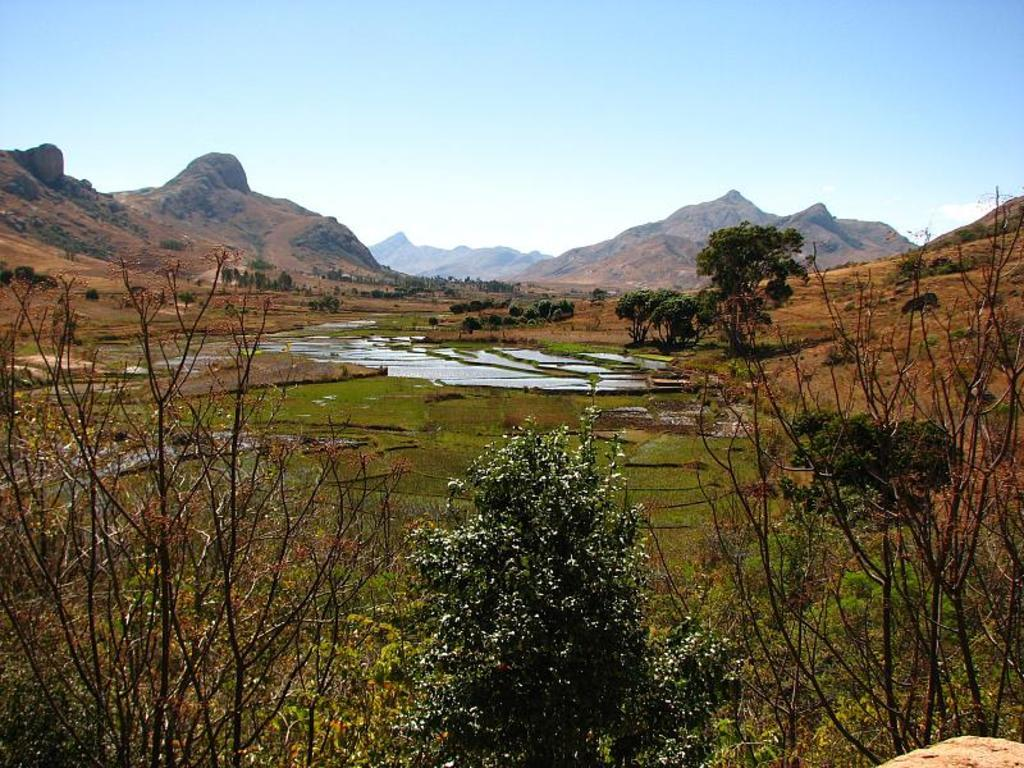What type of landscape is depicted in the image? The image shows farm land. What natural elements can be seen in the image? Water, trees, plants, and grass are visible in the image. What is visible in the background of the image? There are mountains visible in the background of the image. Can you tell me how many basketballs are floating in the water in the image? There are no basketballs present in the image; it features farm land, water, trees, plants, grass, and mountains. What type of bait is being used by the fish in the image? There are no fish or bait present in the image; it features farm land, water, trees, plants, grass, and mountains. 